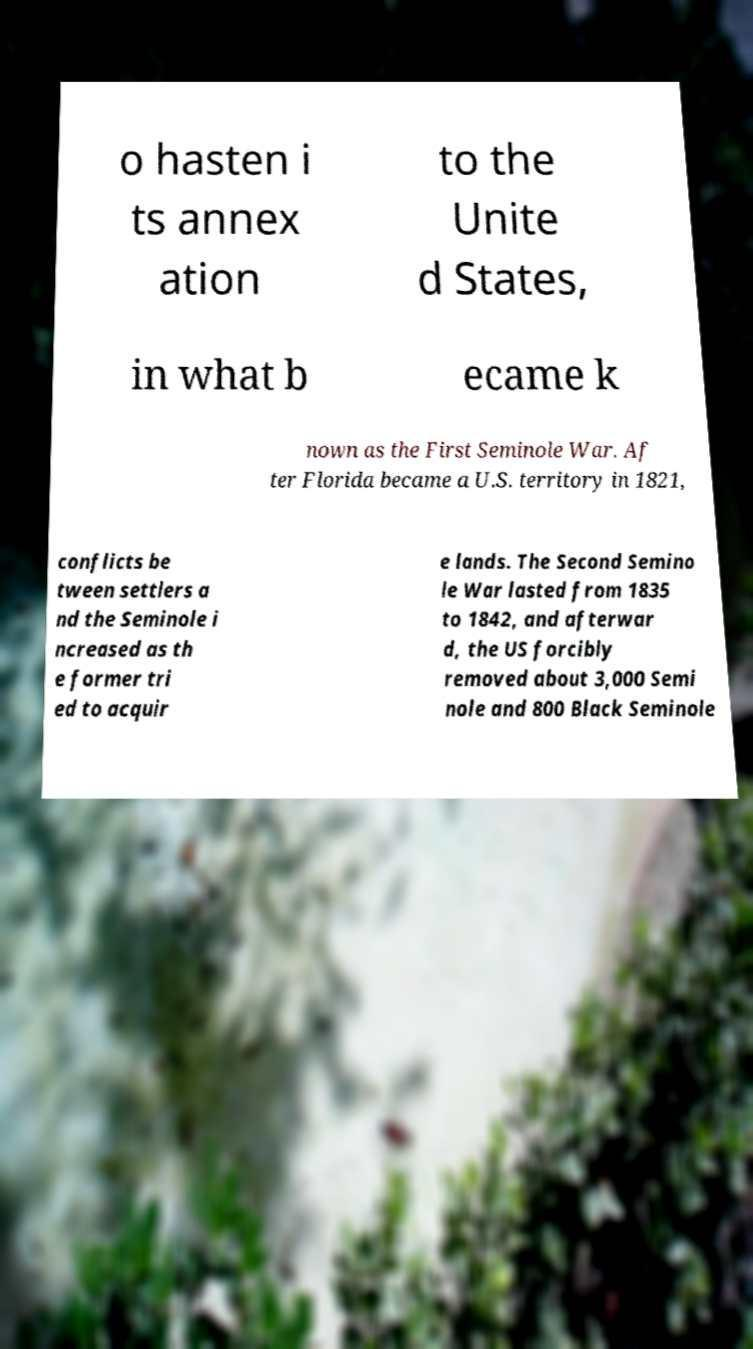Please identify and transcribe the text found in this image. o hasten i ts annex ation to the Unite d States, in what b ecame k nown as the First Seminole War. Af ter Florida became a U.S. territory in 1821, conflicts be tween settlers a nd the Seminole i ncreased as th e former tri ed to acquir e lands. The Second Semino le War lasted from 1835 to 1842, and afterwar d, the US forcibly removed about 3,000 Semi nole and 800 Black Seminole 